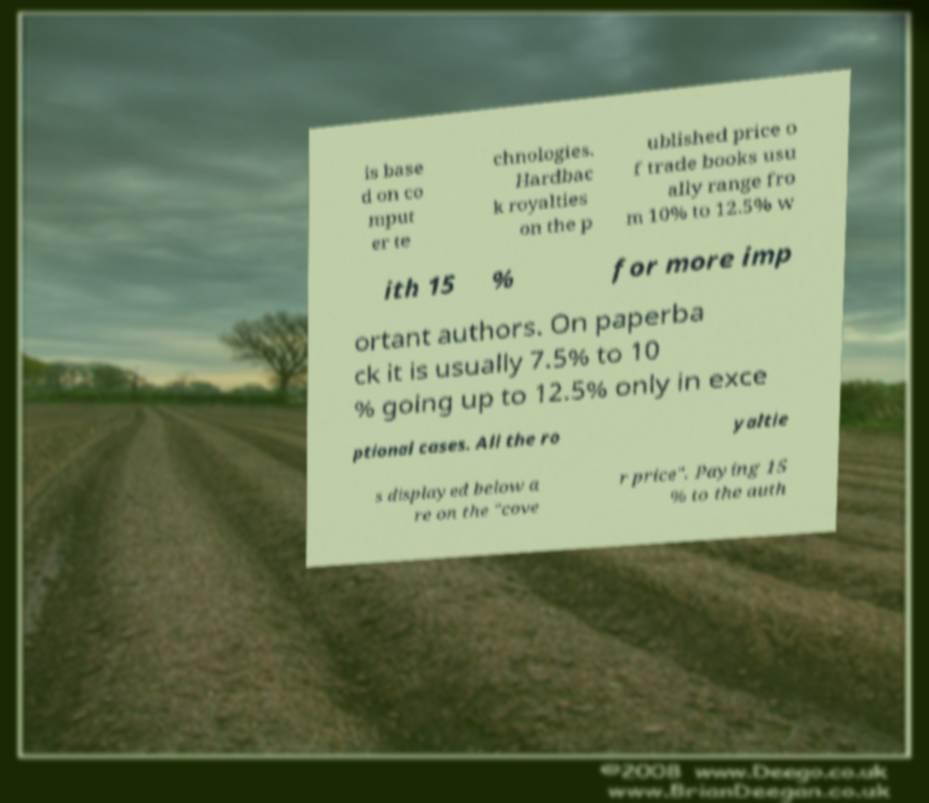Could you extract and type out the text from this image? is base d on co mput er te chnologies. Hardbac k royalties on the p ublished price o f trade books usu ally range fro m 10% to 12.5% w ith 15 % for more imp ortant authors. On paperba ck it is usually 7.5% to 10 % going up to 12.5% only in exce ptional cases. All the ro yaltie s displayed below a re on the "cove r price". Paying 15 % to the auth 